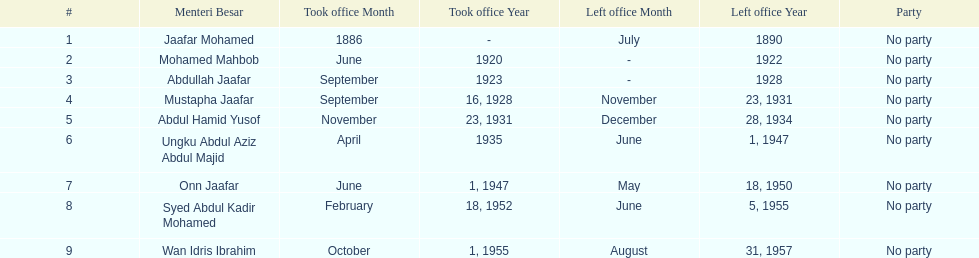Name someone who was not in office more than 4 years. Mohamed Mahbob. 